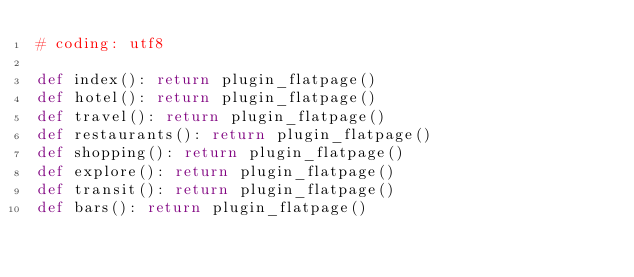<code> <loc_0><loc_0><loc_500><loc_500><_Python_># coding: utf8

def index(): return plugin_flatpage()
def hotel(): return plugin_flatpage()
def travel(): return plugin_flatpage()
def restaurants(): return plugin_flatpage()
def shopping(): return plugin_flatpage()
def explore(): return plugin_flatpage()
def transit(): return plugin_flatpage()
def bars(): return plugin_flatpage()
</code> 